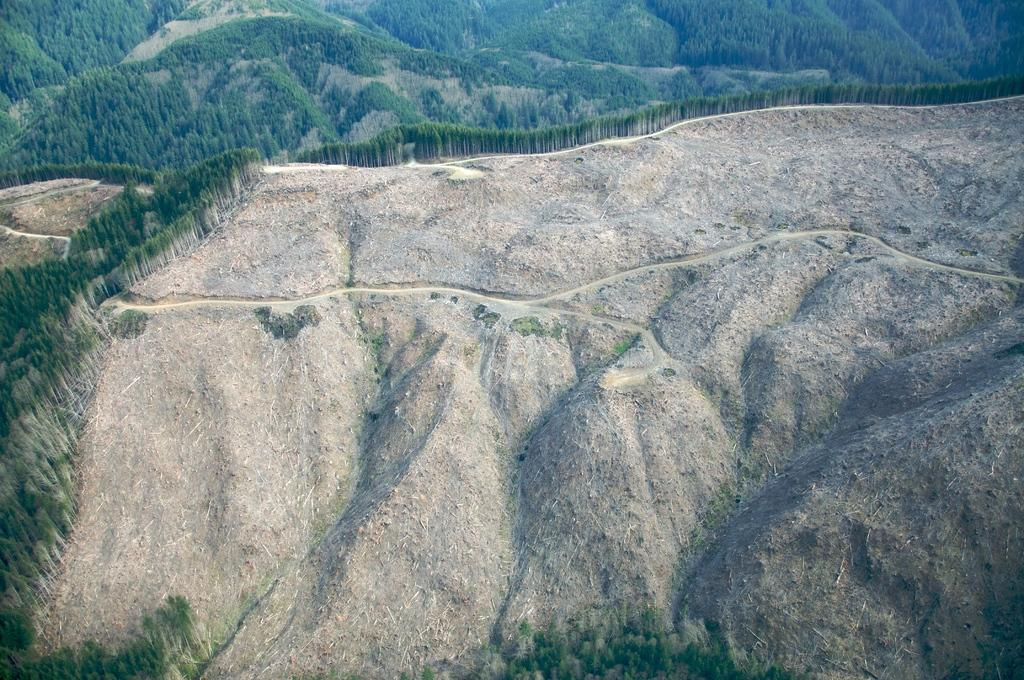What type of landscape is depicted in the image? There is a mountain forest in the image. How many mountains can be seen in the image? There are multiple mountains visible in the image. What type of rings can be seen on the trees in the image? There are no rings visible on the trees in the image. What news can be heard coming from the mountains in the image? There is no sound or news present in the image; it is a still photograph of a mountain forest. 